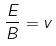<formula> <loc_0><loc_0><loc_500><loc_500>\frac { E } { B } = v</formula> 